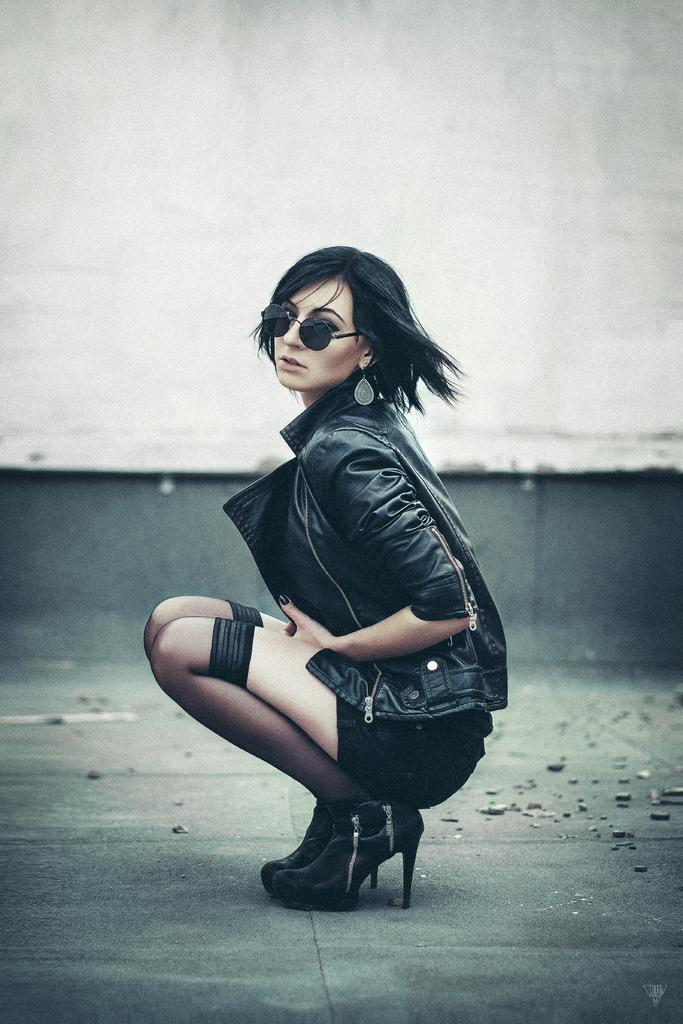Please provide a concise description of this image. In the center of the picture there is a woman in black dress. At the bottom there are stones on the ground. In the background it is well. 